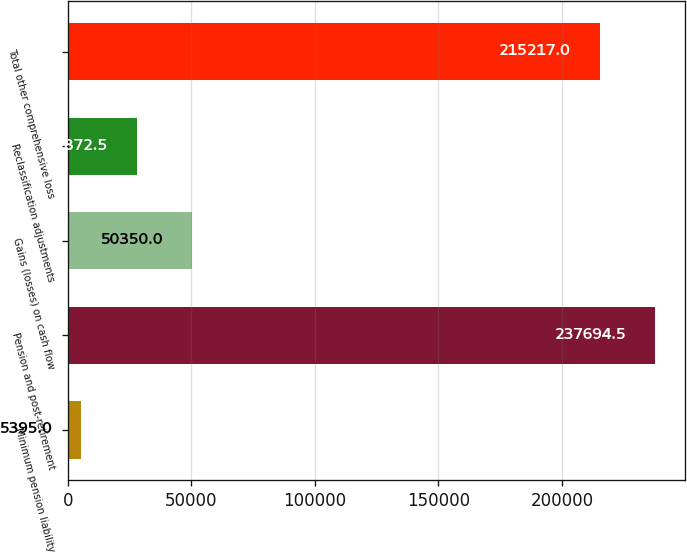<chart> <loc_0><loc_0><loc_500><loc_500><bar_chart><fcel>Minimum pension liability<fcel>Pension and post-retirement<fcel>Gains (losses) on cash flow<fcel>Reclassification adjustments<fcel>Total other comprehensive loss<nl><fcel>5395<fcel>237694<fcel>50350<fcel>27872.5<fcel>215217<nl></chart> 